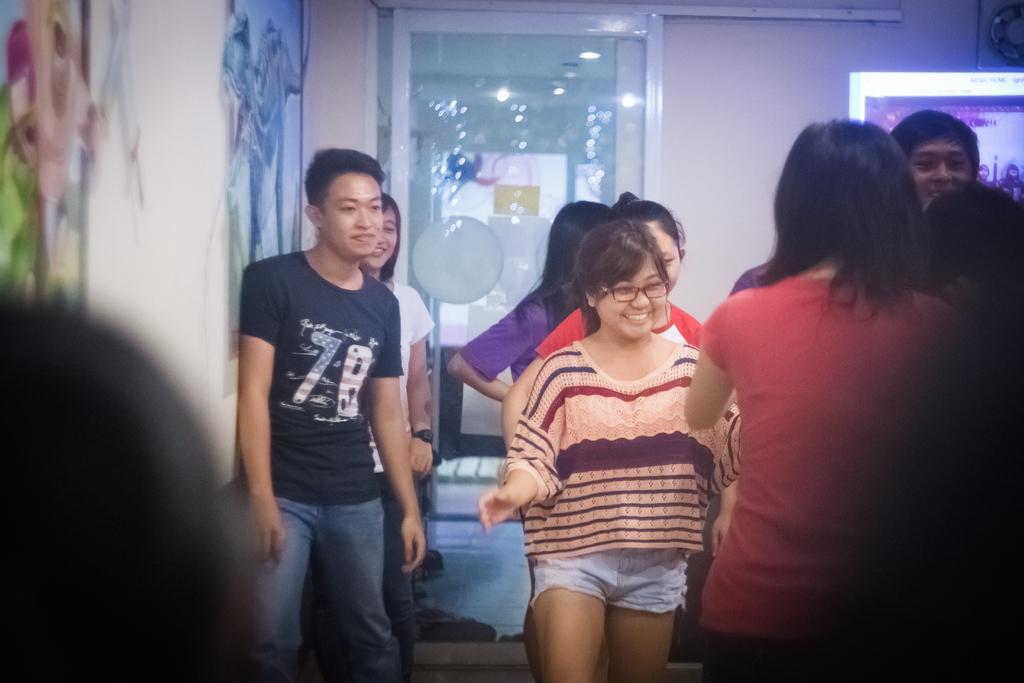Describe this image in one or two sentences. There are persons in different color dresses, standing. Some of them are smiling. On the left side, there are paintings on the white wall. In the background, there is a glass window and there is a white wall. 